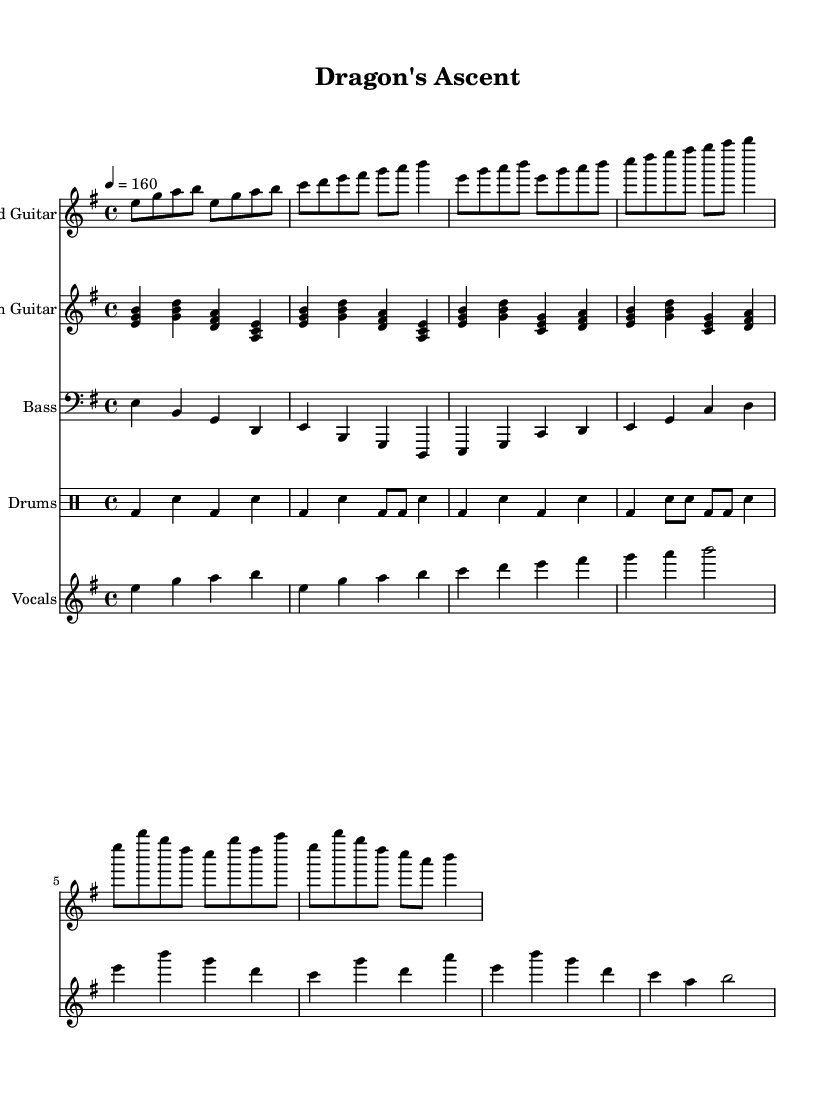What is the key signature of this music? The key signature is E minor, which has one sharp (F#). This can be determined by looking at the key signature at the beginning of the staff, which shows one sharp.
Answer: E minor What is the time signature of the piece? The time signature is 4/4, which is indicated at the beginning of the score. This means there are four beats in each measure, and the quarter note receives one beat.
Answer: 4/4 What is the tempo marking of this sheet music? The tempo is marked at quarter note equals 160 beats per minute. This is evident from the tempo indication at the start, which denotes how fast the piece should be played.
Answer: 160 How many measures are present in the vocals part? There are a total of eight measures in the vocals part. By counting the segments separated by the bar lines in the vocal staff, we can ascertain the total number of measures.
Answer: 8 What is the primary lyrical theme of this song? The primary lyrical theme is heroism and mythological quests, as suggested by the title "Dragon's Ascent" and typical themes in epic power metal. This title hints at a narrative focused on a heroic journey.
Answer: Heroism and mythological quests What is the predominant instrument featured in the introduction? The lead guitar is the predominant instrument featured in the introduction, as it is showcased first in the score layout and plays the main melodic line.
Answer: Lead guitar What is the dynamic range utilized in the drums part? The drums part does not specify dynamics, suggesting a consistent level of intensity. Typically, power metal drums are performed with high energy, often emphasizing either loud or fast playing.
Answer: None specified 